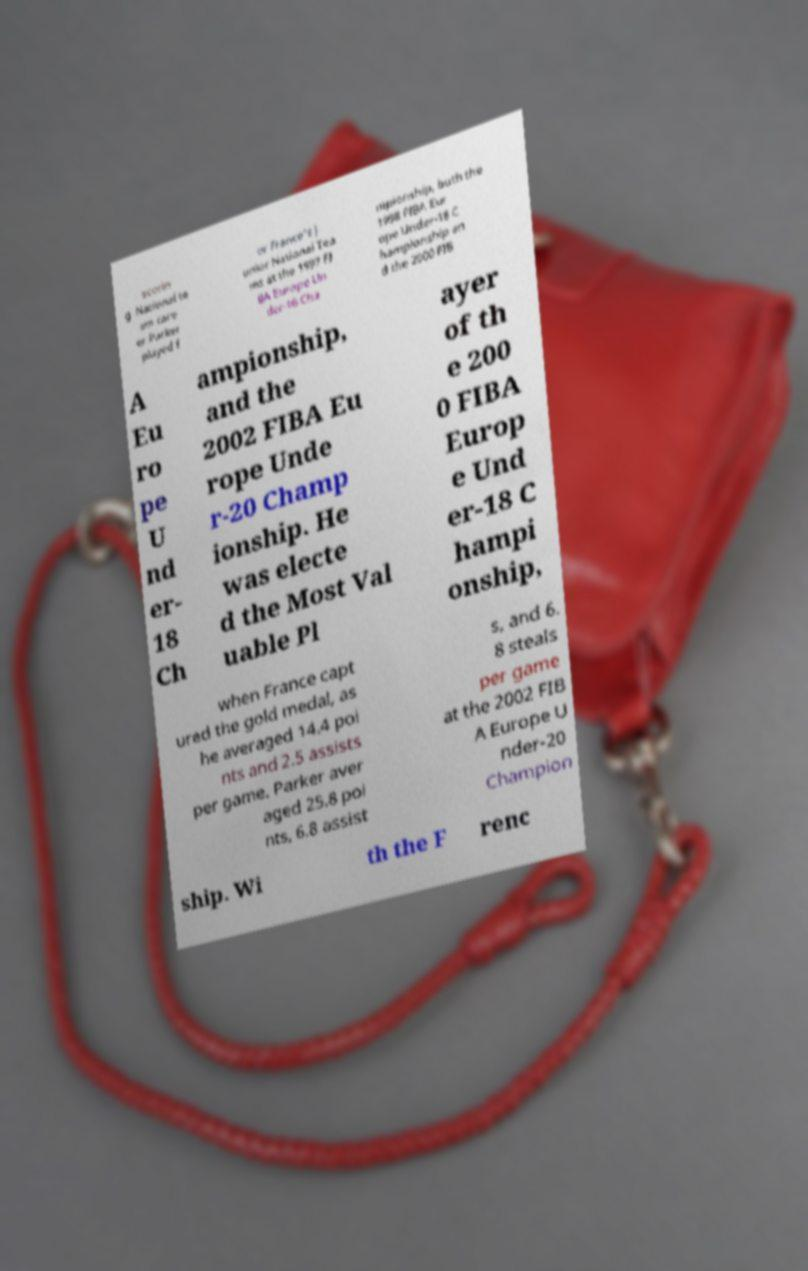Can you accurately transcribe the text from the provided image for me? scorin g .National te am care er.Parker played f or France's J unior National Tea ms at the 1997 FI BA Europe Un der-16 Cha mpionship, both the 1998 FIBA Eur ope Under-18 C hampionship an d the 2000 FIB A Eu ro pe U nd er- 18 Ch ampionship, and the 2002 FIBA Eu rope Unde r-20 Champ ionship. He was electe d the Most Val uable Pl ayer of th e 200 0 FIBA Europ e Und er-18 C hampi onship, when France capt ured the gold medal, as he averaged 14.4 poi nts and 2.5 assists per game. Parker aver aged 25.8 poi nts, 6.8 assist s, and 6. 8 steals per game at the 2002 FIB A Europe U nder-20 Champion ship. Wi th the F renc 